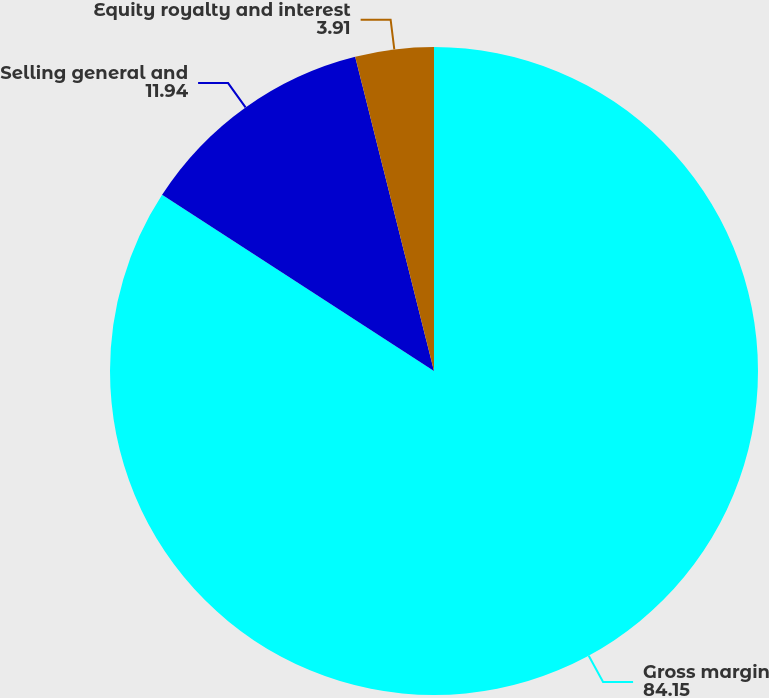Convert chart to OTSL. <chart><loc_0><loc_0><loc_500><loc_500><pie_chart><fcel>Gross margin<fcel>Selling general and<fcel>Equity royalty and interest<nl><fcel>84.15%<fcel>11.94%<fcel>3.91%<nl></chart> 